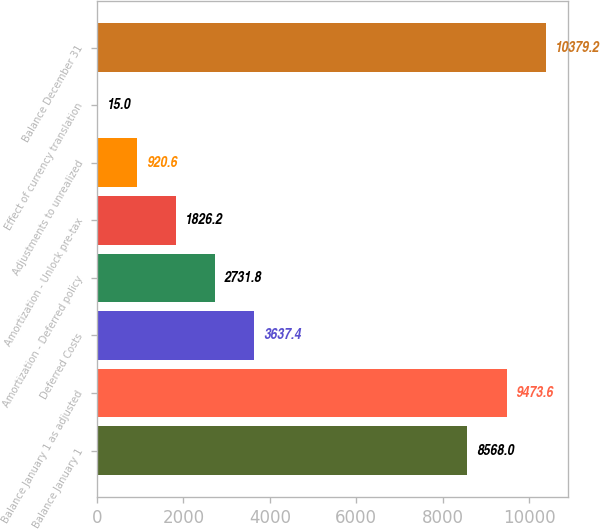Convert chart. <chart><loc_0><loc_0><loc_500><loc_500><bar_chart><fcel>Balance January 1<fcel>Balance January 1 as adjusted<fcel>Deferred Costs<fcel>Amortization - Deferred policy<fcel>Amortization - Unlock pre-tax<fcel>Adjustments to unrealized<fcel>Effect of currency translation<fcel>Balance December 31<nl><fcel>8568<fcel>9473.6<fcel>3637.4<fcel>2731.8<fcel>1826.2<fcel>920.6<fcel>15<fcel>10379.2<nl></chart> 